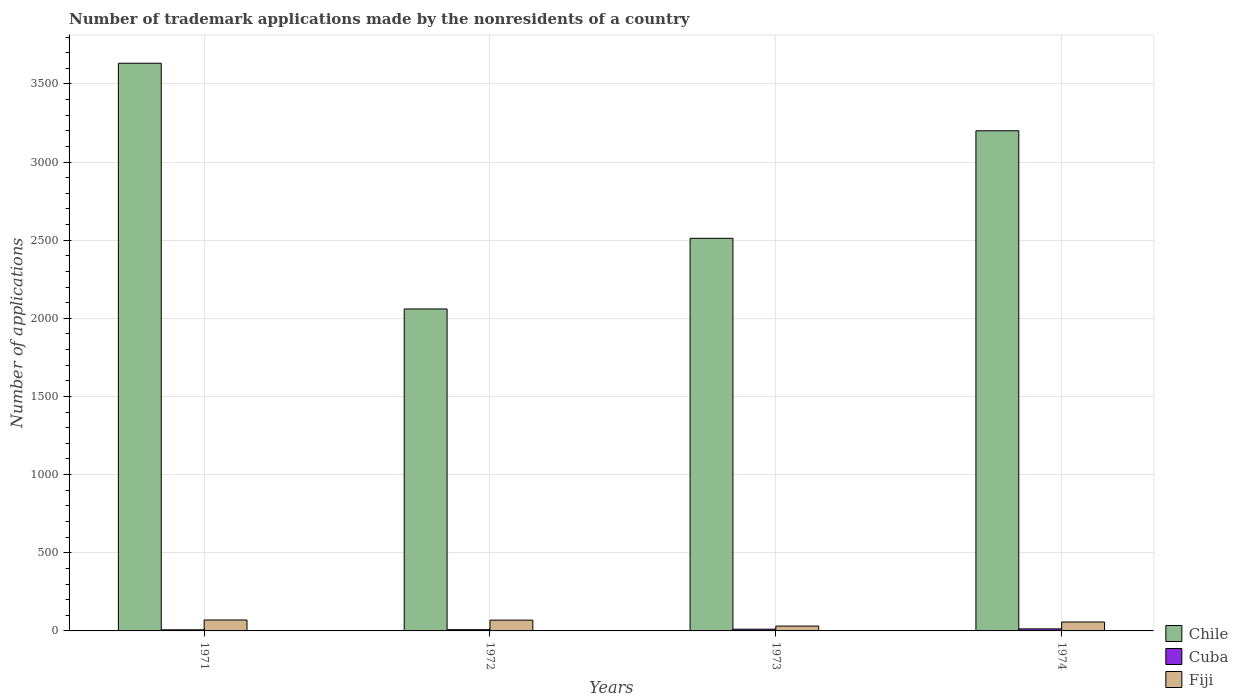How many different coloured bars are there?
Provide a short and direct response. 3. Are the number of bars on each tick of the X-axis equal?
Offer a terse response. Yes. How many bars are there on the 4th tick from the left?
Make the answer very short. 3. How many bars are there on the 1st tick from the right?
Your answer should be compact. 3. What is the label of the 4th group of bars from the left?
Your answer should be compact. 1974. Across all years, what is the maximum number of trademark applications made by the nonresidents in Fiji?
Offer a terse response. 70. Across all years, what is the minimum number of trademark applications made by the nonresidents in Chile?
Ensure brevity in your answer.  2060. In which year was the number of trademark applications made by the nonresidents in Fiji maximum?
Ensure brevity in your answer.  1971. What is the total number of trademark applications made by the nonresidents in Cuba in the graph?
Give a very brief answer. 39. What is the difference between the number of trademark applications made by the nonresidents in Chile in 1971 and that in 1974?
Your response must be concise. 432. What is the difference between the number of trademark applications made by the nonresidents in Chile in 1974 and the number of trademark applications made by the nonresidents in Cuba in 1971?
Provide a short and direct response. 3193. What is the average number of trademark applications made by the nonresidents in Chile per year?
Provide a succinct answer. 2851. In the year 1971, what is the difference between the number of trademark applications made by the nonresidents in Fiji and number of trademark applications made by the nonresidents in Chile?
Keep it short and to the point. -3562. In how many years, is the number of trademark applications made by the nonresidents in Fiji greater than 1200?
Make the answer very short. 0. What is the ratio of the number of trademark applications made by the nonresidents in Cuba in 1971 to that in 1974?
Ensure brevity in your answer.  0.54. Is the sum of the number of trademark applications made by the nonresidents in Cuba in 1971 and 1973 greater than the maximum number of trademark applications made by the nonresidents in Chile across all years?
Keep it short and to the point. No. What does the 3rd bar from the left in 1973 represents?
Give a very brief answer. Fiji. How many bars are there?
Your answer should be compact. 12. What is the difference between two consecutive major ticks on the Y-axis?
Keep it short and to the point. 500. How are the legend labels stacked?
Ensure brevity in your answer.  Vertical. What is the title of the graph?
Keep it short and to the point. Number of trademark applications made by the nonresidents of a country. What is the label or title of the Y-axis?
Your answer should be very brief. Number of applications. What is the Number of applications in Chile in 1971?
Make the answer very short. 3632. What is the Number of applications in Cuba in 1971?
Offer a very short reply. 7. What is the Number of applications of Chile in 1972?
Provide a succinct answer. 2060. What is the Number of applications of Cuba in 1972?
Give a very brief answer. 8. What is the Number of applications in Chile in 1973?
Make the answer very short. 2512. What is the Number of applications in Cuba in 1973?
Make the answer very short. 11. What is the Number of applications in Fiji in 1973?
Ensure brevity in your answer.  31. What is the Number of applications of Chile in 1974?
Ensure brevity in your answer.  3200. What is the Number of applications in Fiji in 1974?
Your response must be concise. 57. Across all years, what is the maximum Number of applications of Chile?
Provide a succinct answer. 3632. Across all years, what is the maximum Number of applications of Fiji?
Your answer should be very brief. 70. Across all years, what is the minimum Number of applications of Chile?
Your answer should be very brief. 2060. Across all years, what is the minimum Number of applications of Fiji?
Give a very brief answer. 31. What is the total Number of applications in Chile in the graph?
Your answer should be compact. 1.14e+04. What is the total Number of applications of Cuba in the graph?
Your response must be concise. 39. What is the total Number of applications of Fiji in the graph?
Give a very brief answer. 227. What is the difference between the Number of applications in Chile in 1971 and that in 1972?
Your answer should be very brief. 1572. What is the difference between the Number of applications in Cuba in 1971 and that in 1972?
Make the answer very short. -1. What is the difference between the Number of applications in Chile in 1971 and that in 1973?
Offer a terse response. 1120. What is the difference between the Number of applications in Fiji in 1971 and that in 1973?
Make the answer very short. 39. What is the difference between the Number of applications of Chile in 1971 and that in 1974?
Provide a succinct answer. 432. What is the difference between the Number of applications in Chile in 1972 and that in 1973?
Your answer should be very brief. -452. What is the difference between the Number of applications in Chile in 1972 and that in 1974?
Make the answer very short. -1140. What is the difference between the Number of applications in Chile in 1973 and that in 1974?
Offer a terse response. -688. What is the difference between the Number of applications of Chile in 1971 and the Number of applications of Cuba in 1972?
Ensure brevity in your answer.  3624. What is the difference between the Number of applications in Chile in 1971 and the Number of applications in Fiji in 1972?
Offer a terse response. 3563. What is the difference between the Number of applications of Cuba in 1971 and the Number of applications of Fiji in 1972?
Your response must be concise. -62. What is the difference between the Number of applications in Chile in 1971 and the Number of applications in Cuba in 1973?
Your response must be concise. 3621. What is the difference between the Number of applications in Chile in 1971 and the Number of applications in Fiji in 1973?
Offer a terse response. 3601. What is the difference between the Number of applications in Chile in 1971 and the Number of applications in Cuba in 1974?
Make the answer very short. 3619. What is the difference between the Number of applications in Chile in 1971 and the Number of applications in Fiji in 1974?
Your answer should be compact. 3575. What is the difference between the Number of applications of Chile in 1972 and the Number of applications of Cuba in 1973?
Ensure brevity in your answer.  2049. What is the difference between the Number of applications in Chile in 1972 and the Number of applications in Fiji in 1973?
Offer a terse response. 2029. What is the difference between the Number of applications in Chile in 1972 and the Number of applications in Cuba in 1974?
Offer a terse response. 2047. What is the difference between the Number of applications of Chile in 1972 and the Number of applications of Fiji in 1974?
Ensure brevity in your answer.  2003. What is the difference between the Number of applications of Cuba in 1972 and the Number of applications of Fiji in 1974?
Ensure brevity in your answer.  -49. What is the difference between the Number of applications in Chile in 1973 and the Number of applications in Cuba in 1974?
Make the answer very short. 2499. What is the difference between the Number of applications of Chile in 1973 and the Number of applications of Fiji in 1974?
Offer a terse response. 2455. What is the difference between the Number of applications of Cuba in 1973 and the Number of applications of Fiji in 1974?
Your answer should be very brief. -46. What is the average Number of applications in Chile per year?
Provide a short and direct response. 2851. What is the average Number of applications in Cuba per year?
Give a very brief answer. 9.75. What is the average Number of applications of Fiji per year?
Ensure brevity in your answer.  56.75. In the year 1971, what is the difference between the Number of applications of Chile and Number of applications of Cuba?
Make the answer very short. 3625. In the year 1971, what is the difference between the Number of applications of Chile and Number of applications of Fiji?
Offer a terse response. 3562. In the year 1971, what is the difference between the Number of applications in Cuba and Number of applications in Fiji?
Provide a short and direct response. -63. In the year 1972, what is the difference between the Number of applications in Chile and Number of applications in Cuba?
Offer a very short reply. 2052. In the year 1972, what is the difference between the Number of applications in Chile and Number of applications in Fiji?
Give a very brief answer. 1991. In the year 1972, what is the difference between the Number of applications of Cuba and Number of applications of Fiji?
Give a very brief answer. -61. In the year 1973, what is the difference between the Number of applications of Chile and Number of applications of Cuba?
Provide a succinct answer. 2501. In the year 1973, what is the difference between the Number of applications of Chile and Number of applications of Fiji?
Your answer should be compact. 2481. In the year 1974, what is the difference between the Number of applications of Chile and Number of applications of Cuba?
Offer a very short reply. 3187. In the year 1974, what is the difference between the Number of applications of Chile and Number of applications of Fiji?
Offer a terse response. 3143. In the year 1974, what is the difference between the Number of applications in Cuba and Number of applications in Fiji?
Offer a very short reply. -44. What is the ratio of the Number of applications of Chile in 1971 to that in 1972?
Give a very brief answer. 1.76. What is the ratio of the Number of applications in Cuba in 1971 to that in 1972?
Provide a succinct answer. 0.88. What is the ratio of the Number of applications in Fiji in 1971 to that in 1972?
Your answer should be compact. 1.01. What is the ratio of the Number of applications in Chile in 1971 to that in 1973?
Your answer should be compact. 1.45. What is the ratio of the Number of applications of Cuba in 1971 to that in 1973?
Provide a short and direct response. 0.64. What is the ratio of the Number of applications of Fiji in 1971 to that in 1973?
Make the answer very short. 2.26. What is the ratio of the Number of applications of Chile in 1971 to that in 1974?
Your response must be concise. 1.14. What is the ratio of the Number of applications in Cuba in 1971 to that in 1974?
Provide a short and direct response. 0.54. What is the ratio of the Number of applications in Fiji in 1971 to that in 1974?
Provide a short and direct response. 1.23. What is the ratio of the Number of applications in Chile in 1972 to that in 1973?
Ensure brevity in your answer.  0.82. What is the ratio of the Number of applications of Cuba in 1972 to that in 1973?
Offer a very short reply. 0.73. What is the ratio of the Number of applications of Fiji in 1972 to that in 1973?
Give a very brief answer. 2.23. What is the ratio of the Number of applications in Chile in 1972 to that in 1974?
Your response must be concise. 0.64. What is the ratio of the Number of applications of Cuba in 1972 to that in 1974?
Offer a terse response. 0.62. What is the ratio of the Number of applications in Fiji in 1972 to that in 1974?
Your answer should be very brief. 1.21. What is the ratio of the Number of applications in Chile in 1973 to that in 1974?
Offer a terse response. 0.79. What is the ratio of the Number of applications of Cuba in 1973 to that in 1974?
Give a very brief answer. 0.85. What is the ratio of the Number of applications in Fiji in 1973 to that in 1974?
Provide a succinct answer. 0.54. What is the difference between the highest and the second highest Number of applications in Chile?
Give a very brief answer. 432. What is the difference between the highest and the lowest Number of applications in Chile?
Your answer should be compact. 1572. What is the difference between the highest and the lowest Number of applications in Cuba?
Offer a very short reply. 6. 